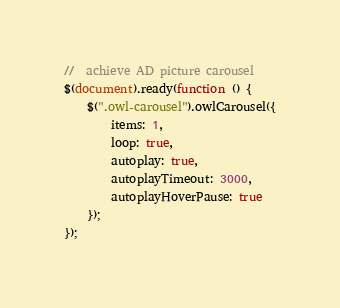Convert code to text. <code><loc_0><loc_0><loc_500><loc_500><_JavaScript_>//  achieve AD picture carousel
$(document).ready(function () {
    $(".owl-carousel").owlCarousel({
        items: 1,
        loop: true,
        autoplay: true,
        autoplayTimeout: 3000,
        autoplayHoverPause: true
    });
});
</code> 